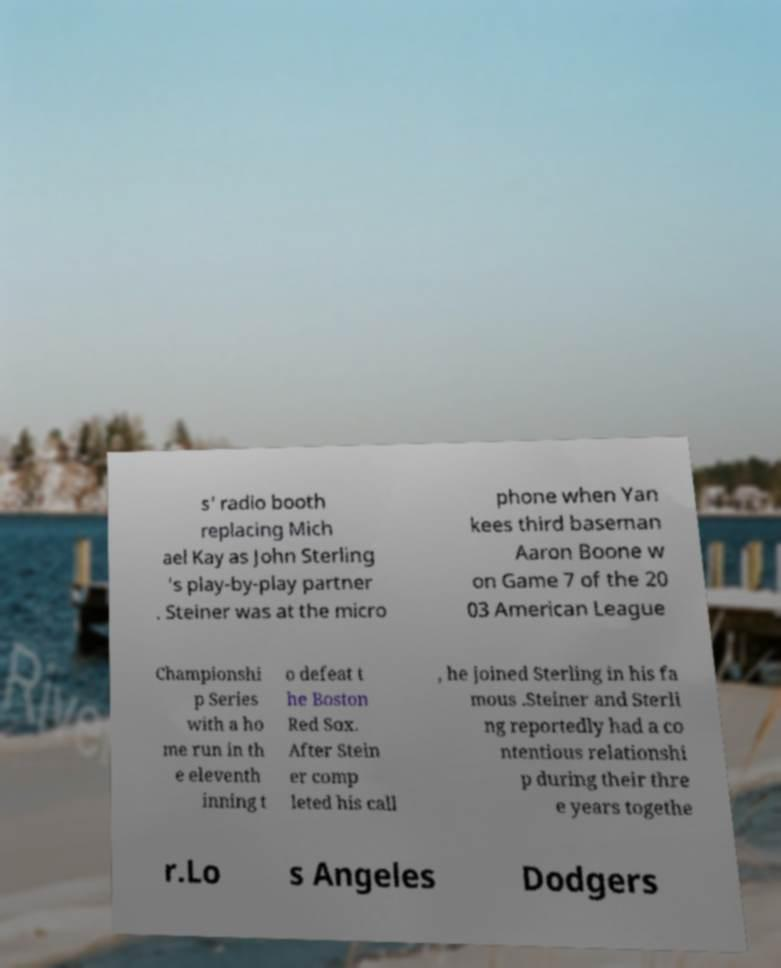For documentation purposes, I need the text within this image transcribed. Could you provide that? s' radio booth replacing Mich ael Kay as John Sterling 's play-by-play partner . Steiner was at the micro phone when Yan kees third baseman Aaron Boone w on Game 7 of the 20 03 American League Championshi p Series with a ho me run in th e eleventh inning t o defeat t he Boston Red Sox. After Stein er comp leted his call , he joined Sterling in his fa mous .Steiner and Sterli ng reportedly had a co ntentious relationshi p during their thre e years togethe r.Lo s Angeles Dodgers 